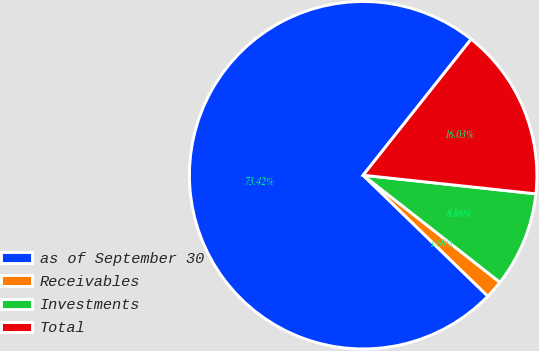Convert chart to OTSL. <chart><loc_0><loc_0><loc_500><loc_500><pie_chart><fcel>as of September 30<fcel>Receivables<fcel>Investments<fcel>Total<nl><fcel>73.42%<fcel>1.69%<fcel>8.86%<fcel>16.03%<nl></chart> 